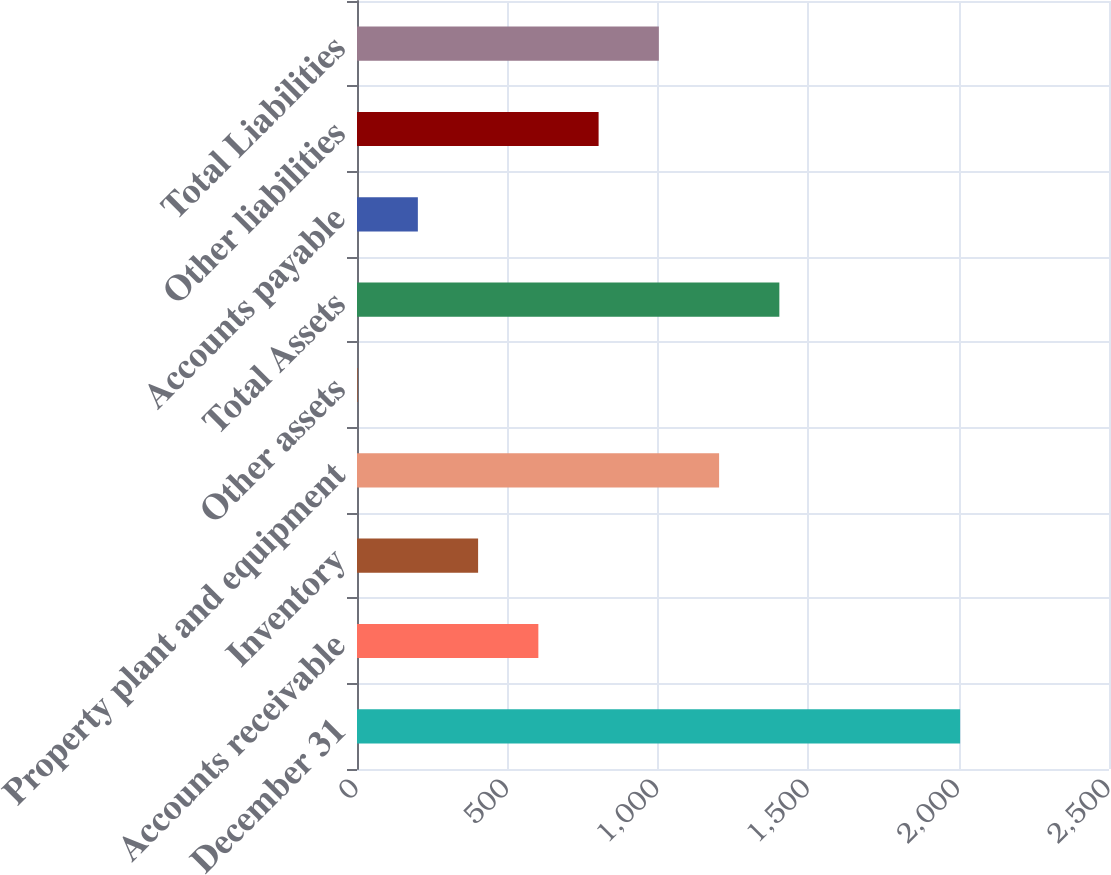Convert chart to OTSL. <chart><loc_0><loc_0><loc_500><loc_500><bar_chart><fcel>December 31<fcel>Accounts receivable<fcel>Inventory<fcel>Property plant and equipment<fcel>Other assets<fcel>Total Assets<fcel>Accounts payable<fcel>Other liabilities<fcel>Total Liabilities<nl><fcel>2005<fcel>602.9<fcel>402.6<fcel>1203.8<fcel>2<fcel>1404.1<fcel>202.3<fcel>803.2<fcel>1003.5<nl></chart> 